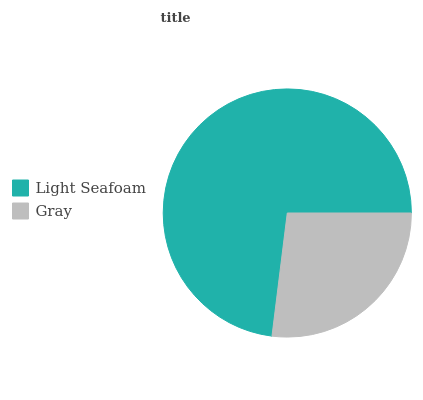Is Gray the minimum?
Answer yes or no. Yes. Is Light Seafoam the maximum?
Answer yes or no. Yes. Is Gray the maximum?
Answer yes or no. No. Is Light Seafoam greater than Gray?
Answer yes or no. Yes. Is Gray less than Light Seafoam?
Answer yes or no. Yes. Is Gray greater than Light Seafoam?
Answer yes or no. No. Is Light Seafoam less than Gray?
Answer yes or no. No. Is Light Seafoam the high median?
Answer yes or no. Yes. Is Gray the low median?
Answer yes or no. Yes. Is Gray the high median?
Answer yes or no. No. Is Light Seafoam the low median?
Answer yes or no. No. 